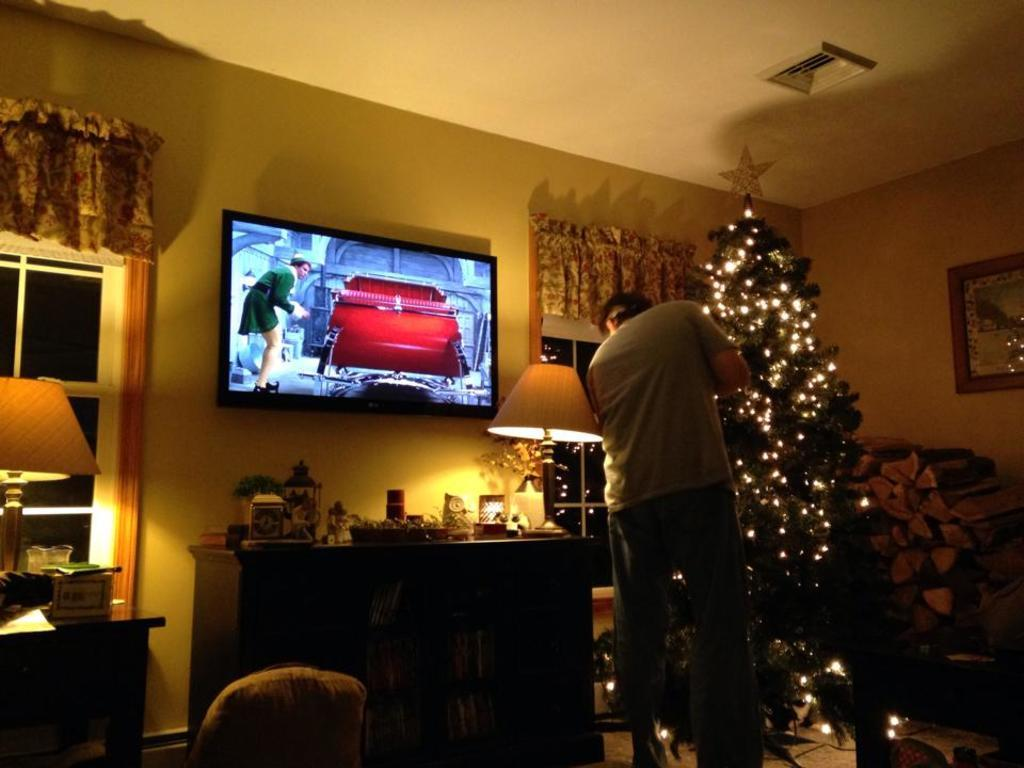What type of room is shown in the image? The image shows an inner view of a room. Who is present in the room? There is a man standing in the room. What is the man doing in the room? The man is lighting a Christmas tree. What electronic device can be seen in the room? There is a television in the room. What piece of furniture is present in the room? There is a table in the room. What source of illumination is visible in the room? There is a light in the room. What type of hair is visible on the man's head in the image? There is no information about the man's hair in the image, so it cannot be determined. 